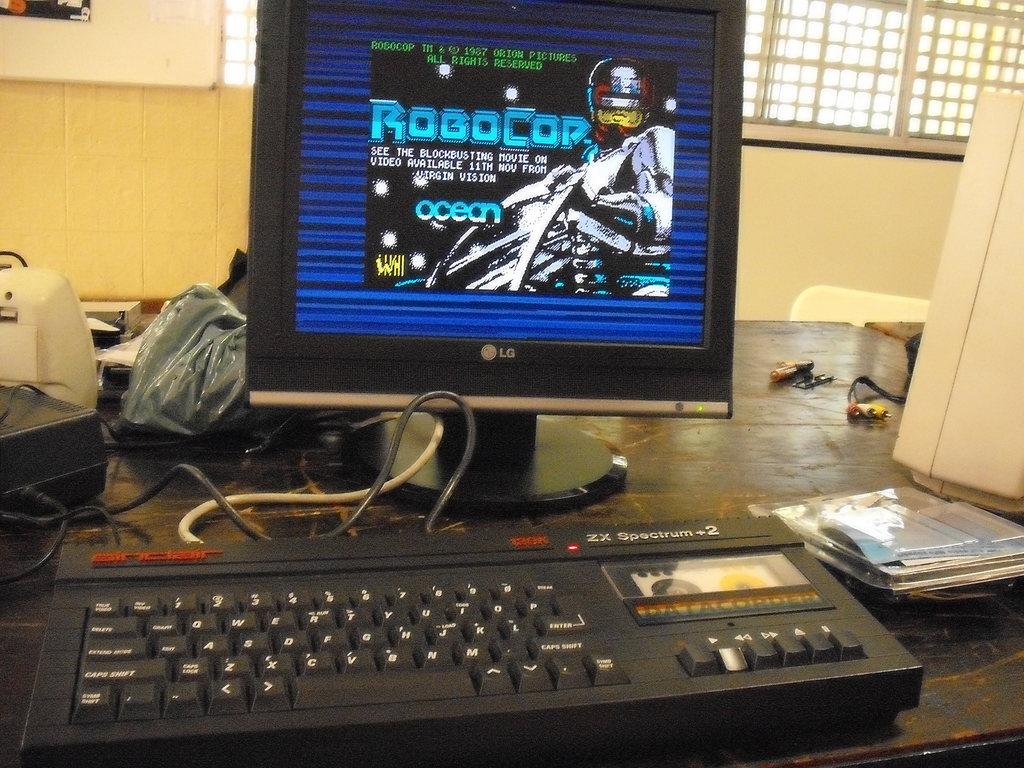What cop is displayed on the monitor?
Ensure brevity in your answer.  Robocop. Is this a video game of robocop?
Offer a terse response. Yes. 